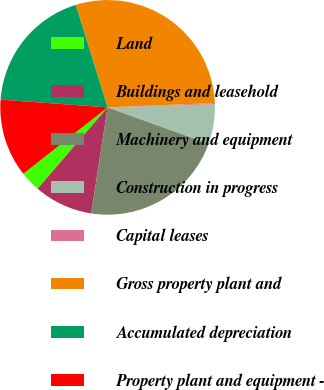Convert chart. <chart><loc_0><loc_0><loc_500><loc_500><pie_chart><fcel>Land<fcel>Buildings and leasehold<fcel>Machinery and equipment<fcel>Construction in progress<fcel>Capital leases<fcel>Gross property plant and<fcel>Accumulated depreciation<fcel>Property plant and equipment -<nl><fcel>3.07%<fcel>8.87%<fcel>21.95%<fcel>5.97%<fcel>0.17%<fcel>29.16%<fcel>19.05%<fcel>11.77%<nl></chart> 